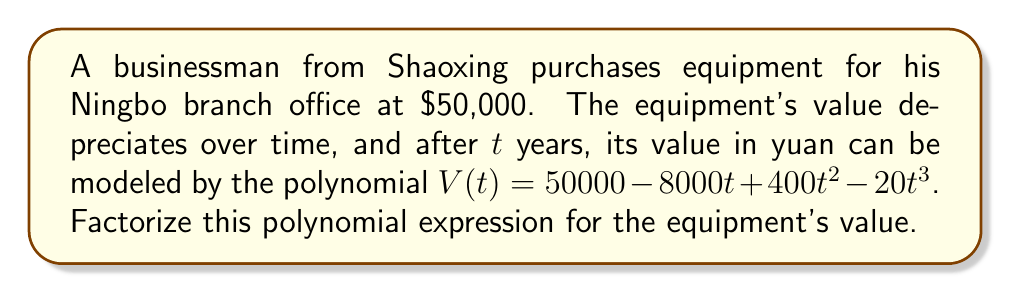Solve this math problem. Let's approach this step-by-step:

1) First, we need to identify the polynomial:
   $V(t) = 50000 - 8000t + 400t^2 - 20t^3$

2) We can factor out the greatest common factor (GCF):
   $V(t) = 20(2500 - 400t + 20t^2 - t^3)$

3) Now, let's focus on the cubic expression inside the parentheses:
   $2500 - 400t + 20t^2 - t^3$

4) This is a cubic polynomial. One way to factor it is to guess one root and then use polynomial long division. Let's try t = 5:

   $2500 - 400(5) + 20(5)^2 - (5)^3 = 2500 - 2000 + 500 - 125 = 875$

   So, t = 5 is not a root. Let's try t = 10:

   $2500 - 400(10) + 20(10)^2 - (10)^3 = 2500 - 4000 + 2000 - 1000 = -500$

5) Now let's try t = 25:

   $2500 - 400(25) + 20(25)^2 - (25)^3 = 2500 - 10000 + 12500 - 15625 = -10625$

6) The value changes sign between t = 0 and t = 25, so there must be a root in this interval. Let's try t = 20:

   $2500 - 400(20) + 20(20)^2 - (20)^3 = 2500 - 8000 + 8000 - 8000 = -5500$

7) Now let's try t = 25:

   $2500 - 400(25) + 20(25)^2 - (25)^3 = 2500 - 10000 + 12500 - 15625 = -10625$

8) The polynomial is still negative at t = 25. Let's try a smaller value, t = 15:

   $2500 - 400(15) + 20(15)^2 - (15)^3 = 2500 - 6000 + 4500 - 3375 = -2375$

9) Let's try t = 5:

   $2500 - 400(5) + 20(5)^2 - (5)^3 = 2500 - 2000 + 500 - 125 = 875$

10) We've found that the polynomial changes sign between t = 5 and t = 15. Let's try t = 10:

    $2500 - 400(10) + 20(10)^2 - (10)^3 = 2500 - 4000 + 2000 - 1000 = -500$

11) The polynomial is zero at t = 10. So (t - 10) is a factor.

12) We can now use polynomial long division to find the other factor:

    $2500 - 400t + 20t^2 - t^3 = (t - 10)(250 + 10t - t^2)$

13) The quadratic factor can be further factored:

    $250 + 10t - t^2 = -(t^2 - 10t - 250) = -(t - 25)(t + 15)$

14) Putting it all together:

    $V(t) = 20(2500 - 400t + 20t^2 - t^3)$
    $V(t) = 20(t - 10)(-(t - 25)(t + 15))$
    $V(t) = -20(t - 10)(t - 25)(t + 15)$

Thus, we have factored the polynomial completely.
Answer: $V(t) = -20(t - 10)(t - 25)(t + 15)$ 